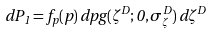Convert formula to latex. <formula><loc_0><loc_0><loc_500><loc_500>d P _ { 1 } = f _ { p } ( p ) \, d p g ( \zeta ^ { D } ; 0 , \sigma _ { \zeta } ^ { D } ) \, d \zeta ^ { D }</formula> 